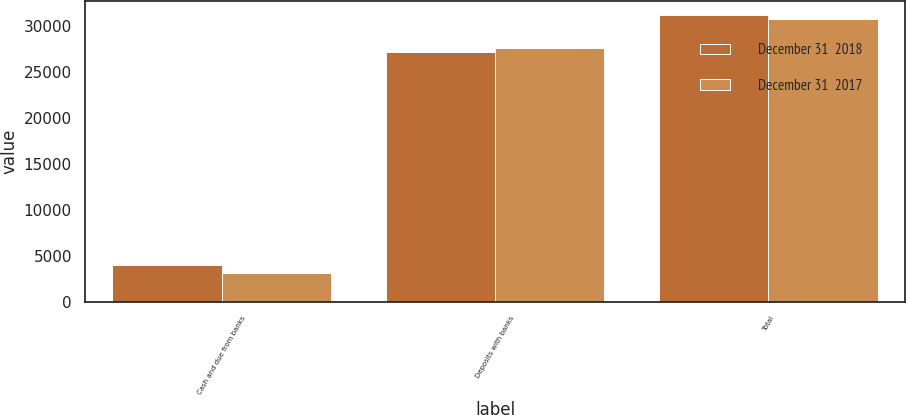<chart> <loc_0><loc_0><loc_500><loc_500><stacked_bar_chart><ecel><fcel>Cash and due from banks<fcel>Deposits with banks<fcel>Total<nl><fcel>December 31  2018<fcel>4000<fcel>27208<fcel>31208<nl><fcel>December 31  2017<fcel>3151<fcel>27664<fcel>30815<nl></chart> 